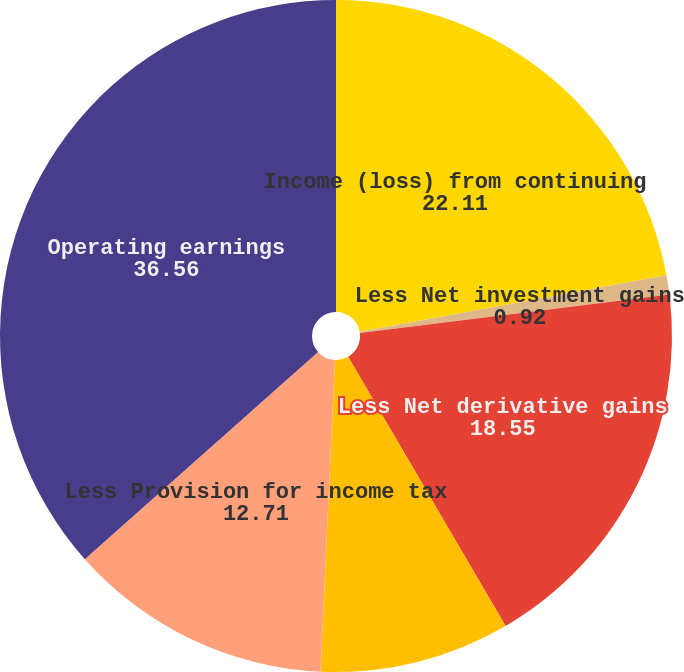Convert chart to OTSL. <chart><loc_0><loc_0><loc_500><loc_500><pie_chart><fcel>Income (loss) from continuing<fcel>Less Net investment gains<fcel>Less Net derivative gains<fcel>Less Other adjustments to<fcel>Less Provision for income tax<fcel>Operating earnings<nl><fcel>22.11%<fcel>0.92%<fcel>18.55%<fcel>9.15%<fcel>12.71%<fcel>36.56%<nl></chart> 